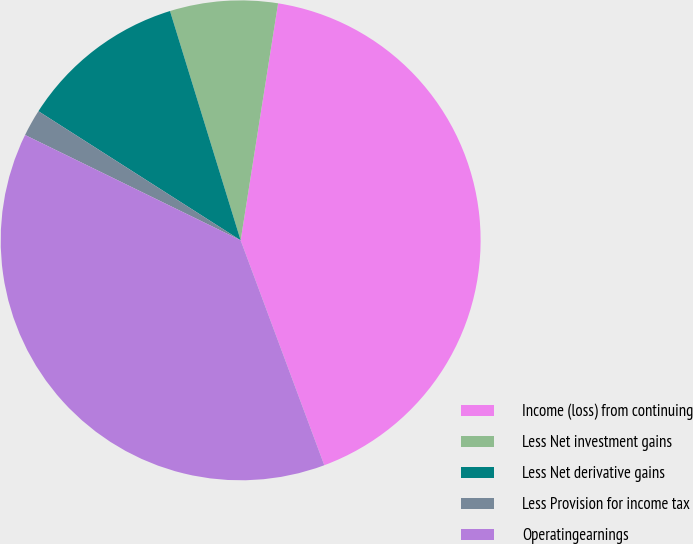Convert chart to OTSL. <chart><loc_0><loc_0><loc_500><loc_500><pie_chart><fcel>Income (loss) from continuing<fcel>Less Net investment gains<fcel>Less Net derivative gains<fcel>Less Provision for income tax<fcel>Operatingearnings<nl><fcel>41.84%<fcel>7.25%<fcel>11.2%<fcel>1.81%<fcel>37.9%<nl></chart> 